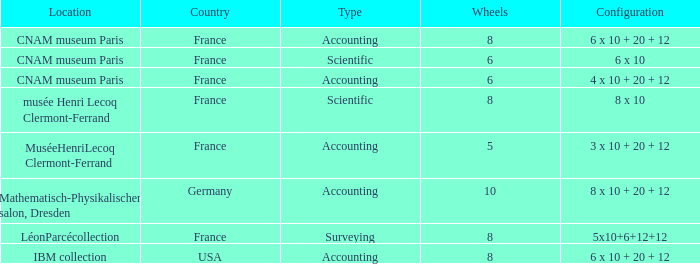What location has surveying as the type? LéonParcécollection. 